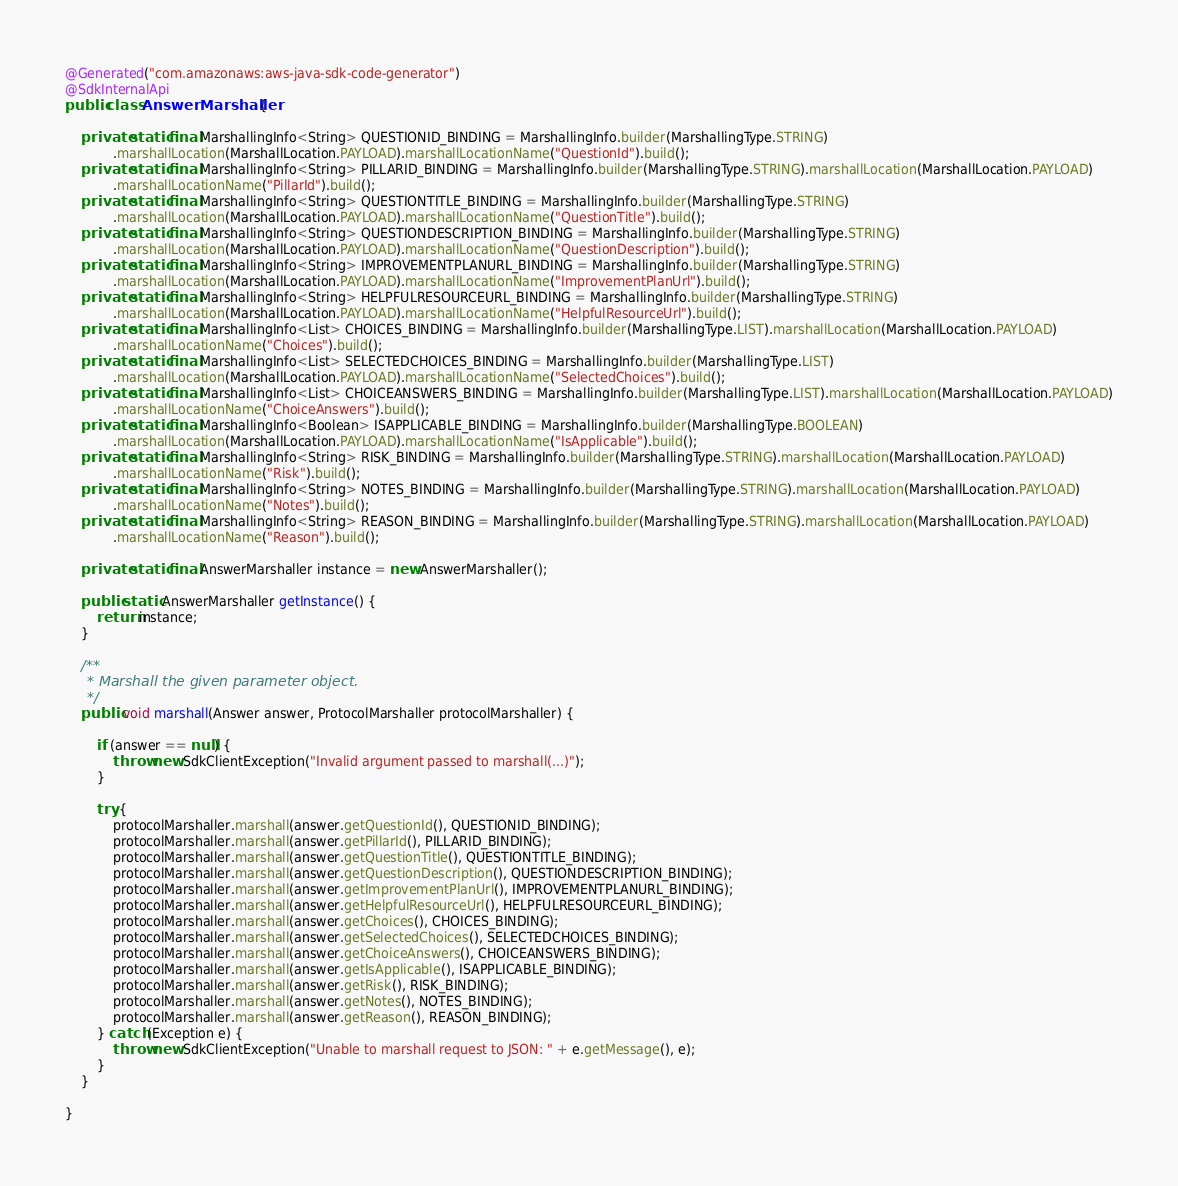Convert code to text. <code><loc_0><loc_0><loc_500><loc_500><_Java_>@Generated("com.amazonaws:aws-java-sdk-code-generator")
@SdkInternalApi
public class AnswerMarshaller {

    private static final MarshallingInfo<String> QUESTIONID_BINDING = MarshallingInfo.builder(MarshallingType.STRING)
            .marshallLocation(MarshallLocation.PAYLOAD).marshallLocationName("QuestionId").build();
    private static final MarshallingInfo<String> PILLARID_BINDING = MarshallingInfo.builder(MarshallingType.STRING).marshallLocation(MarshallLocation.PAYLOAD)
            .marshallLocationName("PillarId").build();
    private static final MarshallingInfo<String> QUESTIONTITLE_BINDING = MarshallingInfo.builder(MarshallingType.STRING)
            .marshallLocation(MarshallLocation.PAYLOAD).marshallLocationName("QuestionTitle").build();
    private static final MarshallingInfo<String> QUESTIONDESCRIPTION_BINDING = MarshallingInfo.builder(MarshallingType.STRING)
            .marshallLocation(MarshallLocation.PAYLOAD).marshallLocationName("QuestionDescription").build();
    private static final MarshallingInfo<String> IMPROVEMENTPLANURL_BINDING = MarshallingInfo.builder(MarshallingType.STRING)
            .marshallLocation(MarshallLocation.PAYLOAD).marshallLocationName("ImprovementPlanUrl").build();
    private static final MarshallingInfo<String> HELPFULRESOURCEURL_BINDING = MarshallingInfo.builder(MarshallingType.STRING)
            .marshallLocation(MarshallLocation.PAYLOAD).marshallLocationName("HelpfulResourceUrl").build();
    private static final MarshallingInfo<List> CHOICES_BINDING = MarshallingInfo.builder(MarshallingType.LIST).marshallLocation(MarshallLocation.PAYLOAD)
            .marshallLocationName("Choices").build();
    private static final MarshallingInfo<List> SELECTEDCHOICES_BINDING = MarshallingInfo.builder(MarshallingType.LIST)
            .marshallLocation(MarshallLocation.PAYLOAD).marshallLocationName("SelectedChoices").build();
    private static final MarshallingInfo<List> CHOICEANSWERS_BINDING = MarshallingInfo.builder(MarshallingType.LIST).marshallLocation(MarshallLocation.PAYLOAD)
            .marshallLocationName("ChoiceAnswers").build();
    private static final MarshallingInfo<Boolean> ISAPPLICABLE_BINDING = MarshallingInfo.builder(MarshallingType.BOOLEAN)
            .marshallLocation(MarshallLocation.PAYLOAD).marshallLocationName("IsApplicable").build();
    private static final MarshallingInfo<String> RISK_BINDING = MarshallingInfo.builder(MarshallingType.STRING).marshallLocation(MarshallLocation.PAYLOAD)
            .marshallLocationName("Risk").build();
    private static final MarshallingInfo<String> NOTES_BINDING = MarshallingInfo.builder(MarshallingType.STRING).marshallLocation(MarshallLocation.PAYLOAD)
            .marshallLocationName("Notes").build();
    private static final MarshallingInfo<String> REASON_BINDING = MarshallingInfo.builder(MarshallingType.STRING).marshallLocation(MarshallLocation.PAYLOAD)
            .marshallLocationName("Reason").build();

    private static final AnswerMarshaller instance = new AnswerMarshaller();

    public static AnswerMarshaller getInstance() {
        return instance;
    }

    /**
     * Marshall the given parameter object.
     */
    public void marshall(Answer answer, ProtocolMarshaller protocolMarshaller) {

        if (answer == null) {
            throw new SdkClientException("Invalid argument passed to marshall(...)");
        }

        try {
            protocolMarshaller.marshall(answer.getQuestionId(), QUESTIONID_BINDING);
            protocolMarshaller.marshall(answer.getPillarId(), PILLARID_BINDING);
            protocolMarshaller.marshall(answer.getQuestionTitle(), QUESTIONTITLE_BINDING);
            protocolMarshaller.marshall(answer.getQuestionDescription(), QUESTIONDESCRIPTION_BINDING);
            protocolMarshaller.marshall(answer.getImprovementPlanUrl(), IMPROVEMENTPLANURL_BINDING);
            protocolMarshaller.marshall(answer.getHelpfulResourceUrl(), HELPFULRESOURCEURL_BINDING);
            protocolMarshaller.marshall(answer.getChoices(), CHOICES_BINDING);
            protocolMarshaller.marshall(answer.getSelectedChoices(), SELECTEDCHOICES_BINDING);
            protocolMarshaller.marshall(answer.getChoiceAnswers(), CHOICEANSWERS_BINDING);
            protocolMarshaller.marshall(answer.getIsApplicable(), ISAPPLICABLE_BINDING);
            protocolMarshaller.marshall(answer.getRisk(), RISK_BINDING);
            protocolMarshaller.marshall(answer.getNotes(), NOTES_BINDING);
            protocolMarshaller.marshall(answer.getReason(), REASON_BINDING);
        } catch (Exception e) {
            throw new SdkClientException("Unable to marshall request to JSON: " + e.getMessage(), e);
        }
    }

}
</code> 